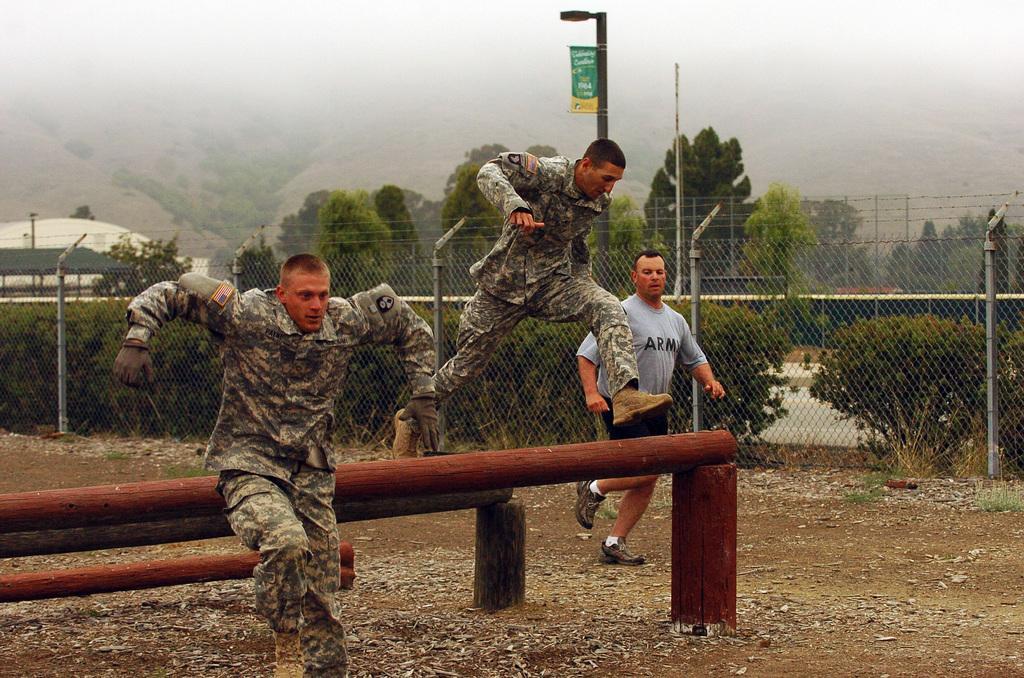In one or two sentences, can you explain what this image depicts? In the image we can see there are men jumping from the wooden pole kept on the ground and there is a man standing on the ground. There is an iron fencing and there are trees. Behind there is a building and there is a clear sky. 